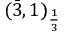<formula> <loc_0><loc_0><loc_500><loc_500>( { \bar { 3 } } , 1 ) _ { \frac { 1 } { 3 } }</formula> 